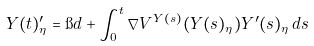Convert formula to latex. <formula><loc_0><loc_0><loc_500><loc_500>Y ( t ) ^ { \prime } _ { \eta } = \i d + \int _ { 0 } ^ { t } \nabla V ^ { Y ( s ) } ( Y ( s ) _ { \eta } ) Y ^ { \prime } ( s ) _ { \eta } \, d s</formula> 